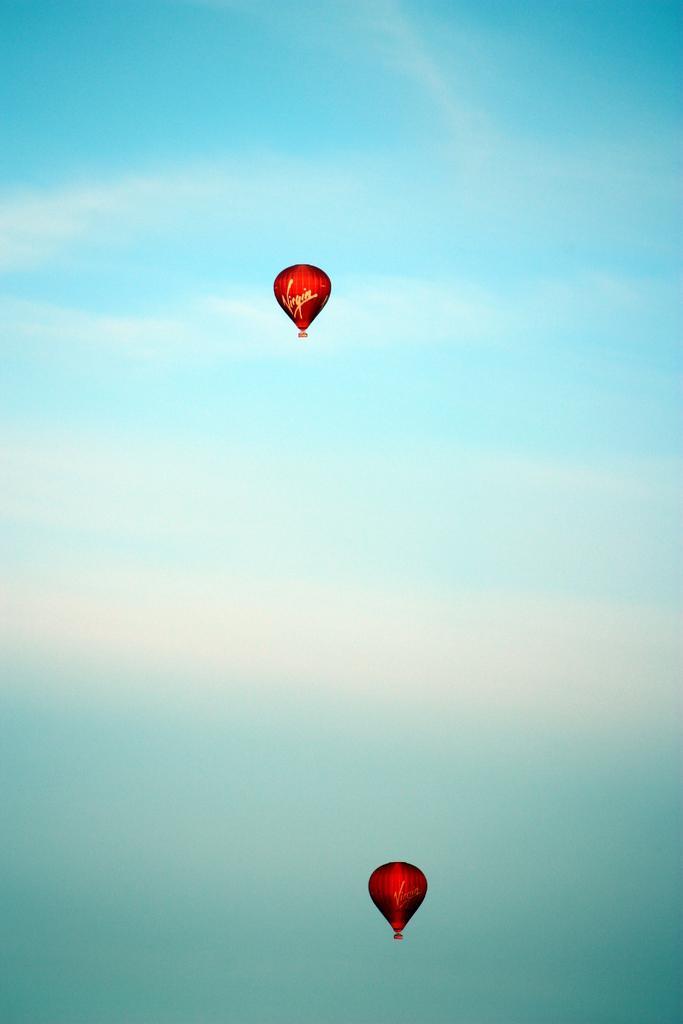Please provide a concise description of this image. In this image we can see parachutes in red color, at above, there is the sky in blue color. 